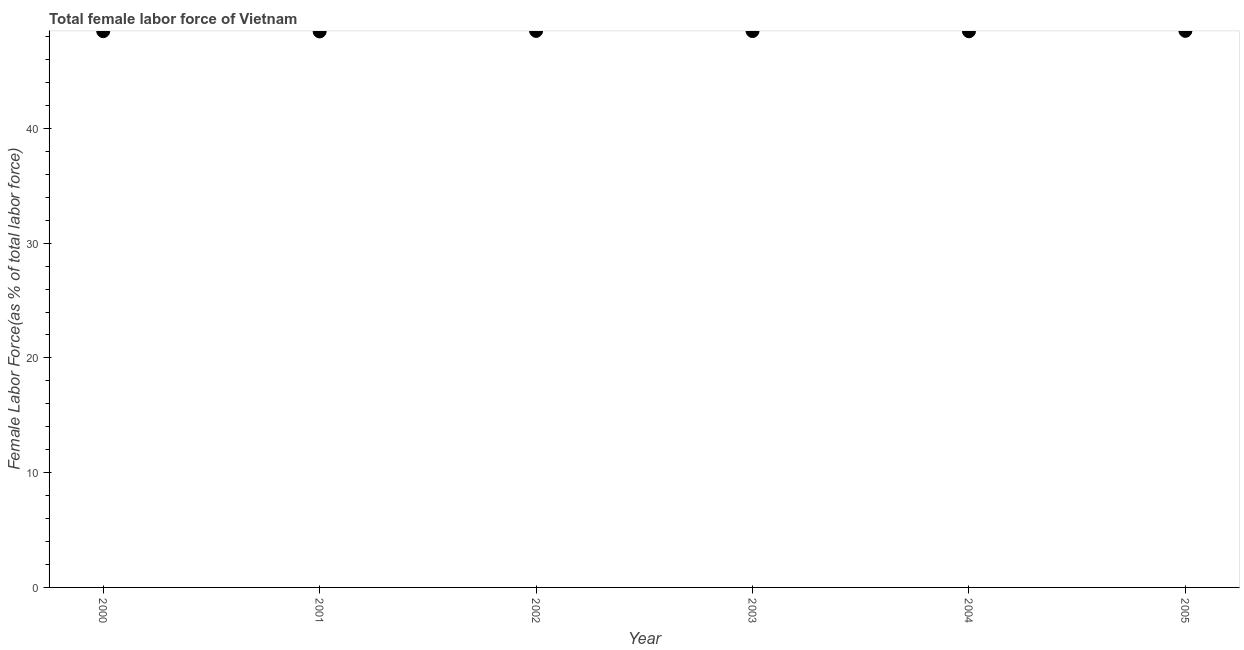What is the total female labor force in 2001?
Provide a succinct answer. 48.45. Across all years, what is the maximum total female labor force?
Offer a terse response. 48.5. Across all years, what is the minimum total female labor force?
Provide a short and direct response. 48.45. In which year was the total female labor force maximum?
Your answer should be compact. 2005. What is the sum of the total female labor force?
Provide a succinct answer. 290.88. What is the difference between the total female labor force in 2001 and 2005?
Your response must be concise. -0.05. What is the average total female labor force per year?
Ensure brevity in your answer.  48.48. What is the median total female labor force?
Your answer should be compact. 48.48. In how many years, is the total female labor force greater than 26 %?
Your response must be concise. 6. Do a majority of the years between 2001 and 2000 (inclusive) have total female labor force greater than 30 %?
Give a very brief answer. No. What is the ratio of the total female labor force in 2001 to that in 2002?
Provide a succinct answer. 1. Is the total female labor force in 2000 less than that in 2005?
Make the answer very short. Yes. What is the difference between the highest and the second highest total female labor force?
Give a very brief answer. 0. What is the difference between the highest and the lowest total female labor force?
Ensure brevity in your answer.  0.05. How many dotlines are there?
Make the answer very short. 1. How many years are there in the graph?
Make the answer very short. 6. Are the values on the major ticks of Y-axis written in scientific E-notation?
Provide a short and direct response. No. Does the graph contain any zero values?
Offer a terse response. No. What is the title of the graph?
Offer a terse response. Total female labor force of Vietnam. What is the label or title of the Y-axis?
Your response must be concise. Female Labor Force(as % of total labor force). What is the Female Labor Force(as % of total labor force) in 2000?
Provide a succinct answer. 48.47. What is the Female Labor Force(as % of total labor force) in 2001?
Your response must be concise. 48.45. What is the Female Labor Force(as % of total labor force) in 2002?
Offer a terse response. 48.5. What is the Female Labor Force(as % of total labor force) in 2003?
Offer a very short reply. 48.49. What is the Female Labor Force(as % of total labor force) in 2004?
Provide a short and direct response. 48.47. What is the Female Labor Force(as % of total labor force) in 2005?
Make the answer very short. 48.5. What is the difference between the Female Labor Force(as % of total labor force) in 2000 and 2001?
Give a very brief answer. 0.02. What is the difference between the Female Labor Force(as % of total labor force) in 2000 and 2002?
Your response must be concise. -0.03. What is the difference between the Female Labor Force(as % of total labor force) in 2000 and 2003?
Offer a terse response. -0.01. What is the difference between the Female Labor Force(as % of total labor force) in 2000 and 2004?
Provide a succinct answer. 0.01. What is the difference between the Female Labor Force(as % of total labor force) in 2000 and 2005?
Offer a terse response. -0.03. What is the difference between the Female Labor Force(as % of total labor force) in 2001 and 2002?
Your answer should be very brief. -0.05. What is the difference between the Female Labor Force(as % of total labor force) in 2001 and 2003?
Your answer should be very brief. -0.03. What is the difference between the Female Labor Force(as % of total labor force) in 2001 and 2004?
Your answer should be compact. -0.01. What is the difference between the Female Labor Force(as % of total labor force) in 2001 and 2005?
Your answer should be compact. -0.05. What is the difference between the Female Labor Force(as % of total labor force) in 2002 and 2003?
Ensure brevity in your answer.  0.01. What is the difference between the Female Labor Force(as % of total labor force) in 2002 and 2004?
Offer a very short reply. 0.03. What is the difference between the Female Labor Force(as % of total labor force) in 2002 and 2005?
Provide a succinct answer. -0. What is the difference between the Female Labor Force(as % of total labor force) in 2003 and 2004?
Provide a succinct answer. 0.02. What is the difference between the Female Labor Force(as % of total labor force) in 2003 and 2005?
Offer a very short reply. -0.02. What is the difference between the Female Labor Force(as % of total labor force) in 2004 and 2005?
Provide a short and direct response. -0.04. What is the ratio of the Female Labor Force(as % of total labor force) in 2000 to that in 2001?
Offer a terse response. 1. What is the ratio of the Female Labor Force(as % of total labor force) in 2000 to that in 2002?
Your response must be concise. 1. What is the ratio of the Female Labor Force(as % of total labor force) in 2000 to that in 2003?
Your response must be concise. 1. What is the ratio of the Female Labor Force(as % of total labor force) in 2001 to that in 2004?
Ensure brevity in your answer.  1. What is the ratio of the Female Labor Force(as % of total labor force) in 2001 to that in 2005?
Keep it short and to the point. 1. What is the ratio of the Female Labor Force(as % of total labor force) in 2002 to that in 2004?
Your answer should be compact. 1. What is the ratio of the Female Labor Force(as % of total labor force) in 2004 to that in 2005?
Offer a very short reply. 1. 